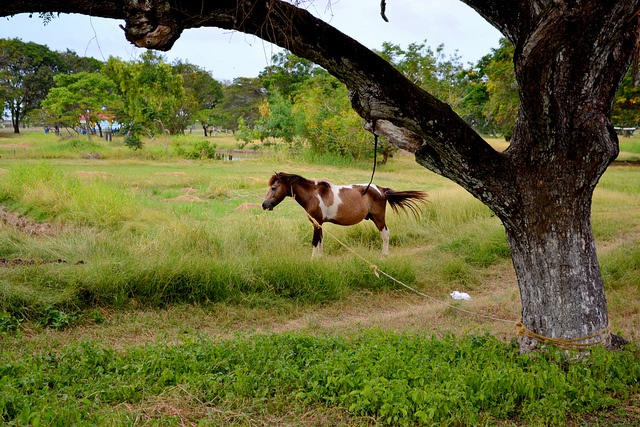Describe the objects in this image and their specific colors. I can see a horse in black, maroon, tan, and gray tones in this image. 